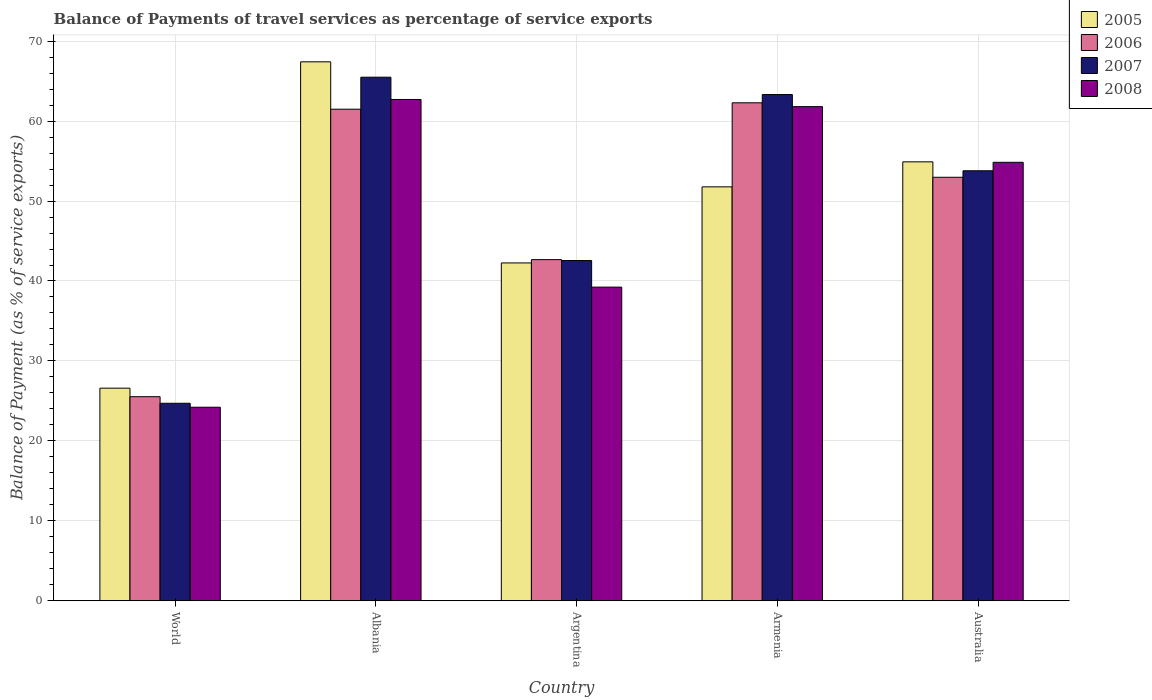How many different coloured bars are there?
Provide a succinct answer. 4. How many groups of bars are there?
Give a very brief answer. 5. What is the label of the 1st group of bars from the left?
Your answer should be very brief. World. What is the balance of payments of travel services in 2008 in Armenia?
Offer a very short reply. 61.81. Across all countries, what is the maximum balance of payments of travel services in 2006?
Offer a very short reply. 62.29. Across all countries, what is the minimum balance of payments of travel services in 2007?
Make the answer very short. 24.7. In which country was the balance of payments of travel services in 2006 maximum?
Your response must be concise. Armenia. In which country was the balance of payments of travel services in 2005 minimum?
Give a very brief answer. World. What is the total balance of payments of travel services in 2007 in the graph?
Your answer should be compact. 249.86. What is the difference between the balance of payments of travel services in 2007 in Armenia and that in World?
Ensure brevity in your answer.  38.62. What is the difference between the balance of payments of travel services in 2008 in Albania and the balance of payments of travel services in 2005 in World?
Give a very brief answer. 36.11. What is the average balance of payments of travel services in 2005 per country?
Provide a succinct answer. 48.59. What is the difference between the balance of payments of travel services of/in 2006 and balance of payments of travel services of/in 2007 in World?
Your answer should be very brief. 0.82. In how many countries, is the balance of payments of travel services in 2007 greater than 60 %?
Provide a succinct answer. 2. What is the ratio of the balance of payments of travel services in 2006 in Albania to that in Argentina?
Offer a terse response. 1.44. Is the balance of payments of travel services in 2007 in Argentina less than that in World?
Make the answer very short. No. What is the difference between the highest and the second highest balance of payments of travel services in 2007?
Offer a very short reply. 11.71. What is the difference between the highest and the lowest balance of payments of travel services in 2005?
Provide a short and direct response. 40.82. Is it the case that in every country, the sum of the balance of payments of travel services in 2007 and balance of payments of travel services in 2005 is greater than the sum of balance of payments of travel services in 2008 and balance of payments of travel services in 2006?
Give a very brief answer. No. What does the 1st bar from the left in World represents?
Your answer should be very brief. 2005. Are all the bars in the graph horizontal?
Give a very brief answer. No. What is the difference between two consecutive major ticks on the Y-axis?
Your answer should be very brief. 10. Does the graph contain grids?
Your response must be concise. Yes. How many legend labels are there?
Your answer should be very brief. 4. What is the title of the graph?
Keep it short and to the point. Balance of Payments of travel services as percentage of service exports. Does "1980" appear as one of the legend labels in the graph?
Provide a short and direct response. No. What is the label or title of the Y-axis?
Offer a terse response. Balance of Payment (as % of service exports). What is the Balance of Payment (as % of service exports) of 2005 in World?
Give a very brief answer. 26.59. What is the Balance of Payment (as % of service exports) in 2006 in World?
Offer a terse response. 25.53. What is the Balance of Payment (as % of service exports) of 2007 in World?
Give a very brief answer. 24.7. What is the Balance of Payment (as % of service exports) in 2008 in World?
Give a very brief answer. 24.21. What is the Balance of Payment (as % of service exports) of 2005 in Albania?
Offer a very short reply. 67.42. What is the Balance of Payment (as % of service exports) in 2006 in Albania?
Give a very brief answer. 61.49. What is the Balance of Payment (as % of service exports) of 2007 in Albania?
Provide a succinct answer. 65.49. What is the Balance of Payment (as % of service exports) in 2008 in Albania?
Your answer should be compact. 62.7. What is the Balance of Payment (as % of service exports) in 2005 in Argentina?
Your answer should be compact. 42.26. What is the Balance of Payment (as % of service exports) in 2006 in Argentina?
Give a very brief answer. 42.67. What is the Balance of Payment (as % of service exports) in 2007 in Argentina?
Your response must be concise. 42.56. What is the Balance of Payment (as % of service exports) of 2008 in Argentina?
Ensure brevity in your answer.  39.23. What is the Balance of Payment (as % of service exports) of 2005 in Armenia?
Give a very brief answer. 51.78. What is the Balance of Payment (as % of service exports) of 2006 in Armenia?
Your answer should be compact. 62.29. What is the Balance of Payment (as % of service exports) of 2007 in Armenia?
Provide a short and direct response. 63.32. What is the Balance of Payment (as % of service exports) of 2008 in Armenia?
Offer a very short reply. 61.81. What is the Balance of Payment (as % of service exports) in 2005 in Australia?
Provide a short and direct response. 54.91. What is the Balance of Payment (as % of service exports) of 2006 in Australia?
Your answer should be compact. 52.97. What is the Balance of Payment (as % of service exports) in 2007 in Australia?
Give a very brief answer. 53.79. What is the Balance of Payment (as % of service exports) of 2008 in Australia?
Keep it short and to the point. 54.85. Across all countries, what is the maximum Balance of Payment (as % of service exports) of 2005?
Your answer should be compact. 67.42. Across all countries, what is the maximum Balance of Payment (as % of service exports) of 2006?
Your response must be concise. 62.29. Across all countries, what is the maximum Balance of Payment (as % of service exports) in 2007?
Keep it short and to the point. 65.49. Across all countries, what is the maximum Balance of Payment (as % of service exports) of 2008?
Offer a very short reply. 62.7. Across all countries, what is the minimum Balance of Payment (as % of service exports) of 2005?
Your answer should be compact. 26.59. Across all countries, what is the minimum Balance of Payment (as % of service exports) in 2006?
Offer a very short reply. 25.53. Across all countries, what is the minimum Balance of Payment (as % of service exports) in 2007?
Offer a very short reply. 24.7. Across all countries, what is the minimum Balance of Payment (as % of service exports) in 2008?
Give a very brief answer. 24.21. What is the total Balance of Payment (as % of service exports) in 2005 in the graph?
Your response must be concise. 242.95. What is the total Balance of Payment (as % of service exports) in 2006 in the graph?
Give a very brief answer. 244.95. What is the total Balance of Payment (as % of service exports) of 2007 in the graph?
Offer a terse response. 249.86. What is the total Balance of Payment (as % of service exports) of 2008 in the graph?
Make the answer very short. 242.8. What is the difference between the Balance of Payment (as % of service exports) in 2005 in World and that in Albania?
Offer a terse response. -40.82. What is the difference between the Balance of Payment (as % of service exports) in 2006 in World and that in Albania?
Offer a very short reply. -35.96. What is the difference between the Balance of Payment (as % of service exports) in 2007 in World and that in Albania?
Offer a very short reply. -40.79. What is the difference between the Balance of Payment (as % of service exports) of 2008 in World and that in Albania?
Make the answer very short. -38.5. What is the difference between the Balance of Payment (as % of service exports) in 2005 in World and that in Argentina?
Provide a short and direct response. -15.66. What is the difference between the Balance of Payment (as % of service exports) of 2006 in World and that in Argentina?
Make the answer very short. -17.15. What is the difference between the Balance of Payment (as % of service exports) of 2007 in World and that in Argentina?
Provide a succinct answer. -17.85. What is the difference between the Balance of Payment (as % of service exports) of 2008 in World and that in Argentina?
Your answer should be compact. -15.03. What is the difference between the Balance of Payment (as % of service exports) in 2005 in World and that in Armenia?
Ensure brevity in your answer.  -25.18. What is the difference between the Balance of Payment (as % of service exports) of 2006 in World and that in Armenia?
Give a very brief answer. -36.76. What is the difference between the Balance of Payment (as % of service exports) in 2007 in World and that in Armenia?
Make the answer very short. -38.62. What is the difference between the Balance of Payment (as % of service exports) of 2008 in World and that in Armenia?
Your response must be concise. -37.6. What is the difference between the Balance of Payment (as % of service exports) in 2005 in World and that in Australia?
Offer a very short reply. -28.31. What is the difference between the Balance of Payment (as % of service exports) of 2006 in World and that in Australia?
Make the answer very short. -27.45. What is the difference between the Balance of Payment (as % of service exports) in 2007 in World and that in Australia?
Make the answer very short. -29.08. What is the difference between the Balance of Payment (as % of service exports) in 2008 in World and that in Australia?
Your answer should be compact. -30.64. What is the difference between the Balance of Payment (as % of service exports) of 2005 in Albania and that in Argentina?
Provide a short and direct response. 25.16. What is the difference between the Balance of Payment (as % of service exports) in 2006 in Albania and that in Argentina?
Make the answer very short. 18.82. What is the difference between the Balance of Payment (as % of service exports) of 2007 in Albania and that in Argentina?
Provide a short and direct response. 22.93. What is the difference between the Balance of Payment (as % of service exports) in 2008 in Albania and that in Argentina?
Give a very brief answer. 23.47. What is the difference between the Balance of Payment (as % of service exports) of 2005 in Albania and that in Armenia?
Your answer should be compact. 15.64. What is the difference between the Balance of Payment (as % of service exports) in 2006 in Albania and that in Armenia?
Provide a short and direct response. -0.8. What is the difference between the Balance of Payment (as % of service exports) in 2007 in Albania and that in Armenia?
Provide a succinct answer. 2.17. What is the difference between the Balance of Payment (as % of service exports) in 2008 in Albania and that in Armenia?
Your answer should be compact. 0.89. What is the difference between the Balance of Payment (as % of service exports) of 2005 in Albania and that in Australia?
Ensure brevity in your answer.  12.51. What is the difference between the Balance of Payment (as % of service exports) in 2006 in Albania and that in Australia?
Your answer should be very brief. 8.52. What is the difference between the Balance of Payment (as % of service exports) of 2007 in Albania and that in Australia?
Your answer should be compact. 11.71. What is the difference between the Balance of Payment (as % of service exports) in 2008 in Albania and that in Australia?
Ensure brevity in your answer.  7.86. What is the difference between the Balance of Payment (as % of service exports) in 2005 in Argentina and that in Armenia?
Your answer should be very brief. -9.52. What is the difference between the Balance of Payment (as % of service exports) of 2006 in Argentina and that in Armenia?
Ensure brevity in your answer.  -19.62. What is the difference between the Balance of Payment (as % of service exports) in 2007 in Argentina and that in Armenia?
Provide a short and direct response. -20.76. What is the difference between the Balance of Payment (as % of service exports) of 2008 in Argentina and that in Armenia?
Your answer should be compact. -22.58. What is the difference between the Balance of Payment (as % of service exports) of 2005 in Argentina and that in Australia?
Give a very brief answer. -12.65. What is the difference between the Balance of Payment (as % of service exports) in 2006 in Argentina and that in Australia?
Your answer should be compact. -10.3. What is the difference between the Balance of Payment (as % of service exports) of 2007 in Argentina and that in Australia?
Ensure brevity in your answer.  -11.23. What is the difference between the Balance of Payment (as % of service exports) in 2008 in Argentina and that in Australia?
Give a very brief answer. -15.61. What is the difference between the Balance of Payment (as % of service exports) in 2005 in Armenia and that in Australia?
Offer a very short reply. -3.13. What is the difference between the Balance of Payment (as % of service exports) in 2006 in Armenia and that in Australia?
Make the answer very short. 9.32. What is the difference between the Balance of Payment (as % of service exports) in 2007 in Armenia and that in Australia?
Your answer should be very brief. 9.53. What is the difference between the Balance of Payment (as % of service exports) in 2008 in Armenia and that in Australia?
Keep it short and to the point. 6.96. What is the difference between the Balance of Payment (as % of service exports) of 2005 in World and the Balance of Payment (as % of service exports) of 2006 in Albania?
Give a very brief answer. -34.9. What is the difference between the Balance of Payment (as % of service exports) in 2005 in World and the Balance of Payment (as % of service exports) in 2007 in Albania?
Offer a terse response. -38.9. What is the difference between the Balance of Payment (as % of service exports) in 2005 in World and the Balance of Payment (as % of service exports) in 2008 in Albania?
Offer a very short reply. -36.11. What is the difference between the Balance of Payment (as % of service exports) in 2006 in World and the Balance of Payment (as % of service exports) in 2007 in Albania?
Offer a terse response. -39.97. What is the difference between the Balance of Payment (as % of service exports) in 2006 in World and the Balance of Payment (as % of service exports) in 2008 in Albania?
Give a very brief answer. -37.18. What is the difference between the Balance of Payment (as % of service exports) of 2007 in World and the Balance of Payment (as % of service exports) of 2008 in Albania?
Provide a succinct answer. -38. What is the difference between the Balance of Payment (as % of service exports) of 2005 in World and the Balance of Payment (as % of service exports) of 2006 in Argentina?
Make the answer very short. -16.08. What is the difference between the Balance of Payment (as % of service exports) of 2005 in World and the Balance of Payment (as % of service exports) of 2007 in Argentina?
Your answer should be very brief. -15.96. What is the difference between the Balance of Payment (as % of service exports) in 2005 in World and the Balance of Payment (as % of service exports) in 2008 in Argentina?
Provide a succinct answer. -12.64. What is the difference between the Balance of Payment (as % of service exports) in 2006 in World and the Balance of Payment (as % of service exports) in 2007 in Argentina?
Make the answer very short. -17.03. What is the difference between the Balance of Payment (as % of service exports) of 2006 in World and the Balance of Payment (as % of service exports) of 2008 in Argentina?
Provide a short and direct response. -13.71. What is the difference between the Balance of Payment (as % of service exports) in 2007 in World and the Balance of Payment (as % of service exports) in 2008 in Argentina?
Offer a very short reply. -14.53. What is the difference between the Balance of Payment (as % of service exports) in 2005 in World and the Balance of Payment (as % of service exports) in 2006 in Armenia?
Ensure brevity in your answer.  -35.7. What is the difference between the Balance of Payment (as % of service exports) of 2005 in World and the Balance of Payment (as % of service exports) of 2007 in Armenia?
Provide a short and direct response. -36.73. What is the difference between the Balance of Payment (as % of service exports) of 2005 in World and the Balance of Payment (as % of service exports) of 2008 in Armenia?
Keep it short and to the point. -35.22. What is the difference between the Balance of Payment (as % of service exports) of 2006 in World and the Balance of Payment (as % of service exports) of 2007 in Armenia?
Provide a succinct answer. -37.79. What is the difference between the Balance of Payment (as % of service exports) in 2006 in World and the Balance of Payment (as % of service exports) in 2008 in Armenia?
Give a very brief answer. -36.28. What is the difference between the Balance of Payment (as % of service exports) of 2007 in World and the Balance of Payment (as % of service exports) of 2008 in Armenia?
Give a very brief answer. -37.11. What is the difference between the Balance of Payment (as % of service exports) of 2005 in World and the Balance of Payment (as % of service exports) of 2006 in Australia?
Provide a short and direct response. -26.38. What is the difference between the Balance of Payment (as % of service exports) in 2005 in World and the Balance of Payment (as % of service exports) in 2007 in Australia?
Offer a very short reply. -27.19. What is the difference between the Balance of Payment (as % of service exports) in 2005 in World and the Balance of Payment (as % of service exports) in 2008 in Australia?
Ensure brevity in your answer.  -28.25. What is the difference between the Balance of Payment (as % of service exports) of 2006 in World and the Balance of Payment (as % of service exports) of 2007 in Australia?
Offer a very short reply. -28.26. What is the difference between the Balance of Payment (as % of service exports) of 2006 in World and the Balance of Payment (as % of service exports) of 2008 in Australia?
Provide a short and direct response. -29.32. What is the difference between the Balance of Payment (as % of service exports) in 2007 in World and the Balance of Payment (as % of service exports) in 2008 in Australia?
Make the answer very short. -30.14. What is the difference between the Balance of Payment (as % of service exports) of 2005 in Albania and the Balance of Payment (as % of service exports) of 2006 in Argentina?
Provide a short and direct response. 24.74. What is the difference between the Balance of Payment (as % of service exports) of 2005 in Albania and the Balance of Payment (as % of service exports) of 2007 in Argentina?
Your answer should be compact. 24.86. What is the difference between the Balance of Payment (as % of service exports) in 2005 in Albania and the Balance of Payment (as % of service exports) in 2008 in Argentina?
Ensure brevity in your answer.  28.18. What is the difference between the Balance of Payment (as % of service exports) of 2006 in Albania and the Balance of Payment (as % of service exports) of 2007 in Argentina?
Offer a terse response. 18.93. What is the difference between the Balance of Payment (as % of service exports) of 2006 in Albania and the Balance of Payment (as % of service exports) of 2008 in Argentina?
Your answer should be compact. 22.26. What is the difference between the Balance of Payment (as % of service exports) of 2007 in Albania and the Balance of Payment (as % of service exports) of 2008 in Argentina?
Give a very brief answer. 26.26. What is the difference between the Balance of Payment (as % of service exports) in 2005 in Albania and the Balance of Payment (as % of service exports) in 2006 in Armenia?
Offer a terse response. 5.13. What is the difference between the Balance of Payment (as % of service exports) of 2005 in Albania and the Balance of Payment (as % of service exports) of 2007 in Armenia?
Your response must be concise. 4.09. What is the difference between the Balance of Payment (as % of service exports) of 2005 in Albania and the Balance of Payment (as % of service exports) of 2008 in Armenia?
Your response must be concise. 5.6. What is the difference between the Balance of Payment (as % of service exports) in 2006 in Albania and the Balance of Payment (as % of service exports) in 2007 in Armenia?
Provide a succinct answer. -1.83. What is the difference between the Balance of Payment (as % of service exports) in 2006 in Albania and the Balance of Payment (as % of service exports) in 2008 in Armenia?
Your answer should be compact. -0.32. What is the difference between the Balance of Payment (as % of service exports) of 2007 in Albania and the Balance of Payment (as % of service exports) of 2008 in Armenia?
Keep it short and to the point. 3.68. What is the difference between the Balance of Payment (as % of service exports) in 2005 in Albania and the Balance of Payment (as % of service exports) in 2006 in Australia?
Provide a succinct answer. 14.44. What is the difference between the Balance of Payment (as % of service exports) in 2005 in Albania and the Balance of Payment (as % of service exports) in 2007 in Australia?
Provide a short and direct response. 13.63. What is the difference between the Balance of Payment (as % of service exports) in 2005 in Albania and the Balance of Payment (as % of service exports) in 2008 in Australia?
Ensure brevity in your answer.  12.57. What is the difference between the Balance of Payment (as % of service exports) in 2006 in Albania and the Balance of Payment (as % of service exports) in 2007 in Australia?
Offer a terse response. 7.7. What is the difference between the Balance of Payment (as % of service exports) of 2006 in Albania and the Balance of Payment (as % of service exports) of 2008 in Australia?
Keep it short and to the point. 6.64. What is the difference between the Balance of Payment (as % of service exports) in 2007 in Albania and the Balance of Payment (as % of service exports) in 2008 in Australia?
Your answer should be compact. 10.65. What is the difference between the Balance of Payment (as % of service exports) in 2005 in Argentina and the Balance of Payment (as % of service exports) in 2006 in Armenia?
Keep it short and to the point. -20.03. What is the difference between the Balance of Payment (as % of service exports) of 2005 in Argentina and the Balance of Payment (as % of service exports) of 2007 in Armenia?
Make the answer very short. -21.06. What is the difference between the Balance of Payment (as % of service exports) of 2005 in Argentina and the Balance of Payment (as % of service exports) of 2008 in Armenia?
Make the answer very short. -19.55. What is the difference between the Balance of Payment (as % of service exports) of 2006 in Argentina and the Balance of Payment (as % of service exports) of 2007 in Armenia?
Offer a terse response. -20.65. What is the difference between the Balance of Payment (as % of service exports) of 2006 in Argentina and the Balance of Payment (as % of service exports) of 2008 in Armenia?
Offer a terse response. -19.14. What is the difference between the Balance of Payment (as % of service exports) in 2007 in Argentina and the Balance of Payment (as % of service exports) in 2008 in Armenia?
Ensure brevity in your answer.  -19.25. What is the difference between the Balance of Payment (as % of service exports) of 2005 in Argentina and the Balance of Payment (as % of service exports) of 2006 in Australia?
Your answer should be very brief. -10.71. What is the difference between the Balance of Payment (as % of service exports) in 2005 in Argentina and the Balance of Payment (as % of service exports) in 2007 in Australia?
Keep it short and to the point. -11.53. What is the difference between the Balance of Payment (as % of service exports) of 2005 in Argentina and the Balance of Payment (as % of service exports) of 2008 in Australia?
Provide a short and direct response. -12.59. What is the difference between the Balance of Payment (as % of service exports) in 2006 in Argentina and the Balance of Payment (as % of service exports) in 2007 in Australia?
Your response must be concise. -11.12. What is the difference between the Balance of Payment (as % of service exports) of 2006 in Argentina and the Balance of Payment (as % of service exports) of 2008 in Australia?
Offer a very short reply. -12.17. What is the difference between the Balance of Payment (as % of service exports) in 2007 in Argentina and the Balance of Payment (as % of service exports) in 2008 in Australia?
Provide a short and direct response. -12.29. What is the difference between the Balance of Payment (as % of service exports) of 2005 in Armenia and the Balance of Payment (as % of service exports) of 2006 in Australia?
Keep it short and to the point. -1.2. What is the difference between the Balance of Payment (as % of service exports) in 2005 in Armenia and the Balance of Payment (as % of service exports) in 2007 in Australia?
Make the answer very short. -2.01. What is the difference between the Balance of Payment (as % of service exports) of 2005 in Armenia and the Balance of Payment (as % of service exports) of 2008 in Australia?
Offer a very short reply. -3.07. What is the difference between the Balance of Payment (as % of service exports) of 2006 in Armenia and the Balance of Payment (as % of service exports) of 2007 in Australia?
Provide a short and direct response. 8.5. What is the difference between the Balance of Payment (as % of service exports) of 2006 in Armenia and the Balance of Payment (as % of service exports) of 2008 in Australia?
Keep it short and to the point. 7.44. What is the difference between the Balance of Payment (as % of service exports) in 2007 in Armenia and the Balance of Payment (as % of service exports) in 2008 in Australia?
Offer a very short reply. 8.47. What is the average Balance of Payment (as % of service exports) in 2005 per country?
Your response must be concise. 48.59. What is the average Balance of Payment (as % of service exports) of 2006 per country?
Your answer should be compact. 48.99. What is the average Balance of Payment (as % of service exports) in 2007 per country?
Provide a short and direct response. 49.97. What is the average Balance of Payment (as % of service exports) of 2008 per country?
Your response must be concise. 48.56. What is the difference between the Balance of Payment (as % of service exports) of 2005 and Balance of Payment (as % of service exports) of 2006 in World?
Give a very brief answer. 1.07. What is the difference between the Balance of Payment (as % of service exports) of 2005 and Balance of Payment (as % of service exports) of 2007 in World?
Provide a succinct answer. 1.89. What is the difference between the Balance of Payment (as % of service exports) of 2005 and Balance of Payment (as % of service exports) of 2008 in World?
Make the answer very short. 2.39. What is the difference between the Balance of Payment (as % of service exports) of 2006 and Balance of Payment (as % of service exports) of 2007 in World?
Your answer should be very brief. 0.82. What is the difference between the Balance of Payment (as % of service exports) in 2006 and Balance of Payment (as % of service exports) in 2008 in World?
Offer a very short reply. 1.32. What is the difference between the Balance of Payment (as % of service exports) in 2007 and Balance of Payment (as % of service exports) in 2008 in World?
Provide a short and direct response. 0.5. What is the difference between the Balance of Payment (as % of service exports) in 2005 and Balance of Payment (as % of service exports) in 2006 in Albania?
Offer a terse response. 5.92. What is the difference between the Balance of Payment (as % of service exports) in 2005 and Balance of Payment (as % of service exports) in 2007 in Albania?
Keep it short and to the point. 1.92. What is the difference between the Balance of Payment (as % of service exports) of 2005 and Balance of Payment (as % of service exports) of 2008 in Albania?
Offer a terse response. 4.71. What is the difference between the Balance of Payment (as % of service exports) of 2006 and Balance of Payment (as % of service exports) of 2007 in Albania?
Keep it short and to the point. -4. What is the difference between the Balance of Payment (as % of service exports) in 2006 and Balance of Payment (as % of service exports) in 2008 in Albania?
Keep it short and to the point. -1.21. What is the difference between the Balance of Payment (as % of service exports) in 2007 and Balance of Payment (as % of service exports) in 2008 in Albania?
Ensure brevity in your answer.  2.79. What is the difference between the Balance of Payment (as % of service exports) in 2005 and Balance of Payment (as % of service exports) in 2006 in Argentina?
Your answer should be very brief. -0.41. What is the difference between the Balance of Payment (as % of service exports) of 2005 and Balance of Payment (as % of service exports) of 2007 in Argentina?
Offer a very short reply. -0.3. What is the difference between the Balance of Payment (as % of service exports) of 2005 and Balance of Payment (as % of service exports) of 2008 in Argentina?
Ensure brevity in your answer.  3.02. What is the difference between the Balance of Payment (as % of service exports) of 2006 and Balance of Payment (as % of service exports) of 2007 in Argentina?
Your answer should be compact. 0.11. What is the difference between the Balance of Payment (as % of service exports) in 2006 and Balance of Payment (as % of service exports) in 2008 in Argentina?
Make the answer very short. 3.44. What is the difference between the Balance of Payment (as % of service exports) of 2007 and Balance of Payment (as % of service exports) of 2008 in Argentina?
Keep it short and to the point. 3.32. What is the difference between the Balance of Payment (as % of service exports) in 2005 and Balance of Payment (as % of service exports) in 2006 in Armenia?
Your answer should be very brief. -10.51. What is the difference between the Balance of Payment (as % of service exports) in 2005 and Balance of Payment (as % of service exports) in 2007 in Armenia?
Provide a short and direct response. -11.54. What is the difference between the Balance of Payment (as % of service exports) of 2005 and Balance of Payment (as % of service exports) of 2008 in Armenia?
Make the answer very short. -10.03. What is the difference between the Balance of Payment (as % of service exports) of 2006 and Balance of Payment (as % of service exports) of 2007 in Armenia?
Your answer should be compact. -1.03. What is the difference between the Balance of Payment (as % of service exports) of 2006 and Balance of Payment (as % of service exports) of 2008 in Armenia?
Offer a terse response. 0.48. What is the difference between the Balance of Payment (as % of service exports) of 2007 and Balance of Payment (as % of service exports) of 2008 in Armenia?
Your response must be concise. 1.51. What is the difference between the Balance of Payment (as % of service exports) of 2005 and Balance of Payment (as % of service exports) of 2006 in Australia?
Provide a short and direct response. 1.93. What is the difference between the Balance of Payment (as % of service exports) in 2005 and Balance of Payment (as % of service exports) in 2007 in Australia?
Your answer should be compact. 1.12. What is the difference between the Balance of Payment (as % of service exports) in 2005 and Balance of Payment (as % of service exports) in 2008 in Australia?
Your response must be concise. 0.06. What is the difference between the Balance of Payment (as % of service exports) of 2006 and Balance of Payment (as % of service exports) of 2007 in Australia?
Offer a terse response. -0.81. What is the difference between the Balance of Payment (as % of service exports) of 2006 and Balance of Payment (as % of service exports) of 2008 in Australia?
Your answer should be compact. -1.87. What is the difference between the Balance of Payment (as % of service exports) of 2007 and Balance of Payment (as % of service exports) of 2008 in Australia?
Provide a succinct answer. -1.06. What is the ratio of the Balance of Payment (as % of service exports) in 2005 in World to that in Albania?
Make the answer very short. 0.39. What is the ratio of the Balance of Payment (as % of service exports) of 2006 in World to that in Albania?
Provide a short and direct response. 0.42. What is the ratio of the Balance of Payment (as % of service exports) in 2007 in World to that in Albania?
Your answer should be compact. 0.38. What is the ratio of the Balance of Payment (as % of service exports) of 2008 in World to that in Albania?
Provide a succinct answer. 0.39. What is the ratio of the Balance of Payment (as % of service exports) of 2005 in World to that in Argentina?
Your answer should be compact. 0.63. What is the ratio of the Balance of Payment (as % of service exports) in 2006 in World to that in Argentina?
Provide a succinct answer. 0.6. What is the ratio of the Balance of Payment (as % of service exports) in 2007 in World to that in Argentina?
Ensure brevity in your answer.  0.58. What is the ratio of the Balance of Payment (as % of service exports) of 2008 in World to that in Argentina?
Offer a very short reply. 0.62. What is the ratio of the Balance of Payment (as % of service exports) of 2005 in World to that in Armenia?
Provide a short and direct response. 0.51. What is the ratio of the Balance of Payment (as % of service exports) of 2006 in World to that in Armenia?
Provide a short and direct response. 0.41. What is the ratio of the Balance of Payment (as % of service exports) of 2007 in World to that in Armenia?
Provide a short and direct response. 0.39. What is the ratio of the Balance of Payment (as % of service exports) of 2008 in World to that in Armenia?
Offer a very short reply. 0.39. What is the ratio of the Balance of Payment (as % of service exports) of 2005 in World to that in Australia?
Make the answer very short. 0.48. What is the ratio of the Balance of Payment (as % of service exports) in 2006 in World to that in Australia?
Offer a very short reply. 0.48. What is the ratio of the Balance of Payment (as % of service exports) in 2007 in World to that in Australia?
Your response must be concise. 0.46. What is the ratio of the Balance of Payment (as % of service exports) in 2008 in World to that in Australia?
Keep it short and to the point. 0.44. What is the ratio of the Balance of Payment (as % of service exports) in 2005 in Albania to that in Argentina?
Make the answer very short. 1.6. What is the ratio of the Balance of Payment (as % of service exports) in 2006 in Albania to that in Argentina?
Offer a very short reply. 1.44. What is the ratio of the Balance of Payment (as % of service exports) of 2007 in Albania to that in Argentina?
Your answer should be very brief. 1.54. What is the ratio of the Balance of Payment (as % of service exports) of 2008 in Albania to that in Argentina?
Make the answer very short. 1.6. What is the ratio of the Balance of Payment (as % of service exports) of 2005 in Albania to that in Armenia?
Make the answer very short. 1.3. What is the ratio of the Balance of Payment (as % of service exports) in 2006 in Albania to that in Armenia?
Offer a very short reply. 0.99. What is the ratio of the Balance of Payment (as % of service exports) of 2007 in Albania to that in Armenia?
Your answer should be very brief. 1.03. What is the ratio of the Balance of Payment (as % of service exports) in 2008 in Albania to that in Armenia?
Your answer should be very brief. 1.01. What is the ratio of the Balance of Payment (as % of service exports) of 2005 in Albania to that in Australia?
Give a very brief answer. 1.23. What is the ratio of the Balance of Payment (as % of service exports) of 2006 in Albania to that in Australia?
Offer a very short reply. 1.16. What is the ratio of the Balance of Payment (as % of service exports) in 2007 in Albania to that in Australia?
Provide a succinct answer. 1.22. What is the ratio of the Balance of Payment (as % of service exports) in 2008 in Albania to that in Australia?
Make the answer very short. 1.14. What is the ratio of the Balance of Payment (as % of service exports) of 2005 in Argentina to that in Armenia?
Offer a terse response. 0.82. What is the ratio of the Balance of Payment (as % of service exports) of 2006 in Argentina to that in Armenia?
Provide a succinct answer. 0.69. What is the ratio of the Balance of Payment (as % of service exports) in 2007 in Argentina to that in Armenia?
Your response must be concise. 0.67. What is the ratio of the Balance of Payment (as % of service exports) of 2008 in Argentina to that in Armenia?
Your answer should be very brief. 0.63. What is the ratio of the Balance of Payment (as % of service exports) of 2005 in Argentina to that in Australia?
Make the answer very short. 0.77. What is the ratio of the Balance of Payment (as % of service exports) in 2006 in Argentina to that in Australia?
Provide a short and direct response. 0.81. What is the ratio of the Balance of Payment (as % of service exports) of 2007 in Argentina to that in Australia?
Offer a terse response. 0.79. What is the ratio of the Balance of Payment (as % of service exports) of 2008 in Argentina to that in Australia?
Give a very brief answer. 0.72. What is the ratio of the Balance of Payment (as % of service exports) of 2005 in Armenia to that in Australia?
Make the answer very short. 0.94. What is the ratio of the Balance of Payment (as % of service exports) of 2006 in Armenia to that in Australia?
Your answer should be compact. 1.18. What is the ratio of the Balance of Payment (as % of service exports) in 2007 in Armenia to that in Australia?
Give a very brief answer. 1.18. What is the ratio of the Balance of Payment (as % of service exports) of 2008 in Armenia to that in Australia?
Your response must be concise. 1.13. What is the difference between the highest and the second highest Balance of Payment (as % of service exports) of 2005?
Ensure brevity in your answer.  12.51. What is the difference between the highest and the second highest Balance of Payment (as % of service exports) in 2006?
Give a very brief answer. 0.8. What is the difference between the highest and the second highest Balance of Payment (as % of service exports) in 2007?
Keep it short and to the point. 2.17. What is the difference between the highest and the second highest Balance of Payment (as % of service exports) of 2008?
Give a very brief answer. 0.89. What is the difference between the highest and the lowest Balance of Payment (as % of service exports) in 2005?
Your response must be concise. 40.82. What is the difference between the highest and the lowest Balance of Payment (as % of service exports) in 2006?
Your answer should be very brief. 36.76. What is the difference between the highest and the lowest Balance of Payment (as % of service exports) of 2007?
Provide a short and direct response. 40.79. What is the difference between the highest and the lowest Balance of Payment (as % of service exports) in 2008?
Your answer should be very brief. 38.5. 